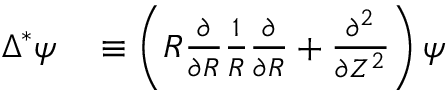<formula> <loc_0><loc_0><loc_500><loc_500>\begin{array} { r l } { \Delta ^ { * } \psi } & \equiv \left ( R \frac { \partial } { \partial R } \frac { 1 } { R } \frac { \partial } { \partial R } + \frac { \partial ^ { 2 } } { \partial Z ^ { 2 } } \right ) \psi } \end{array}</formula> 